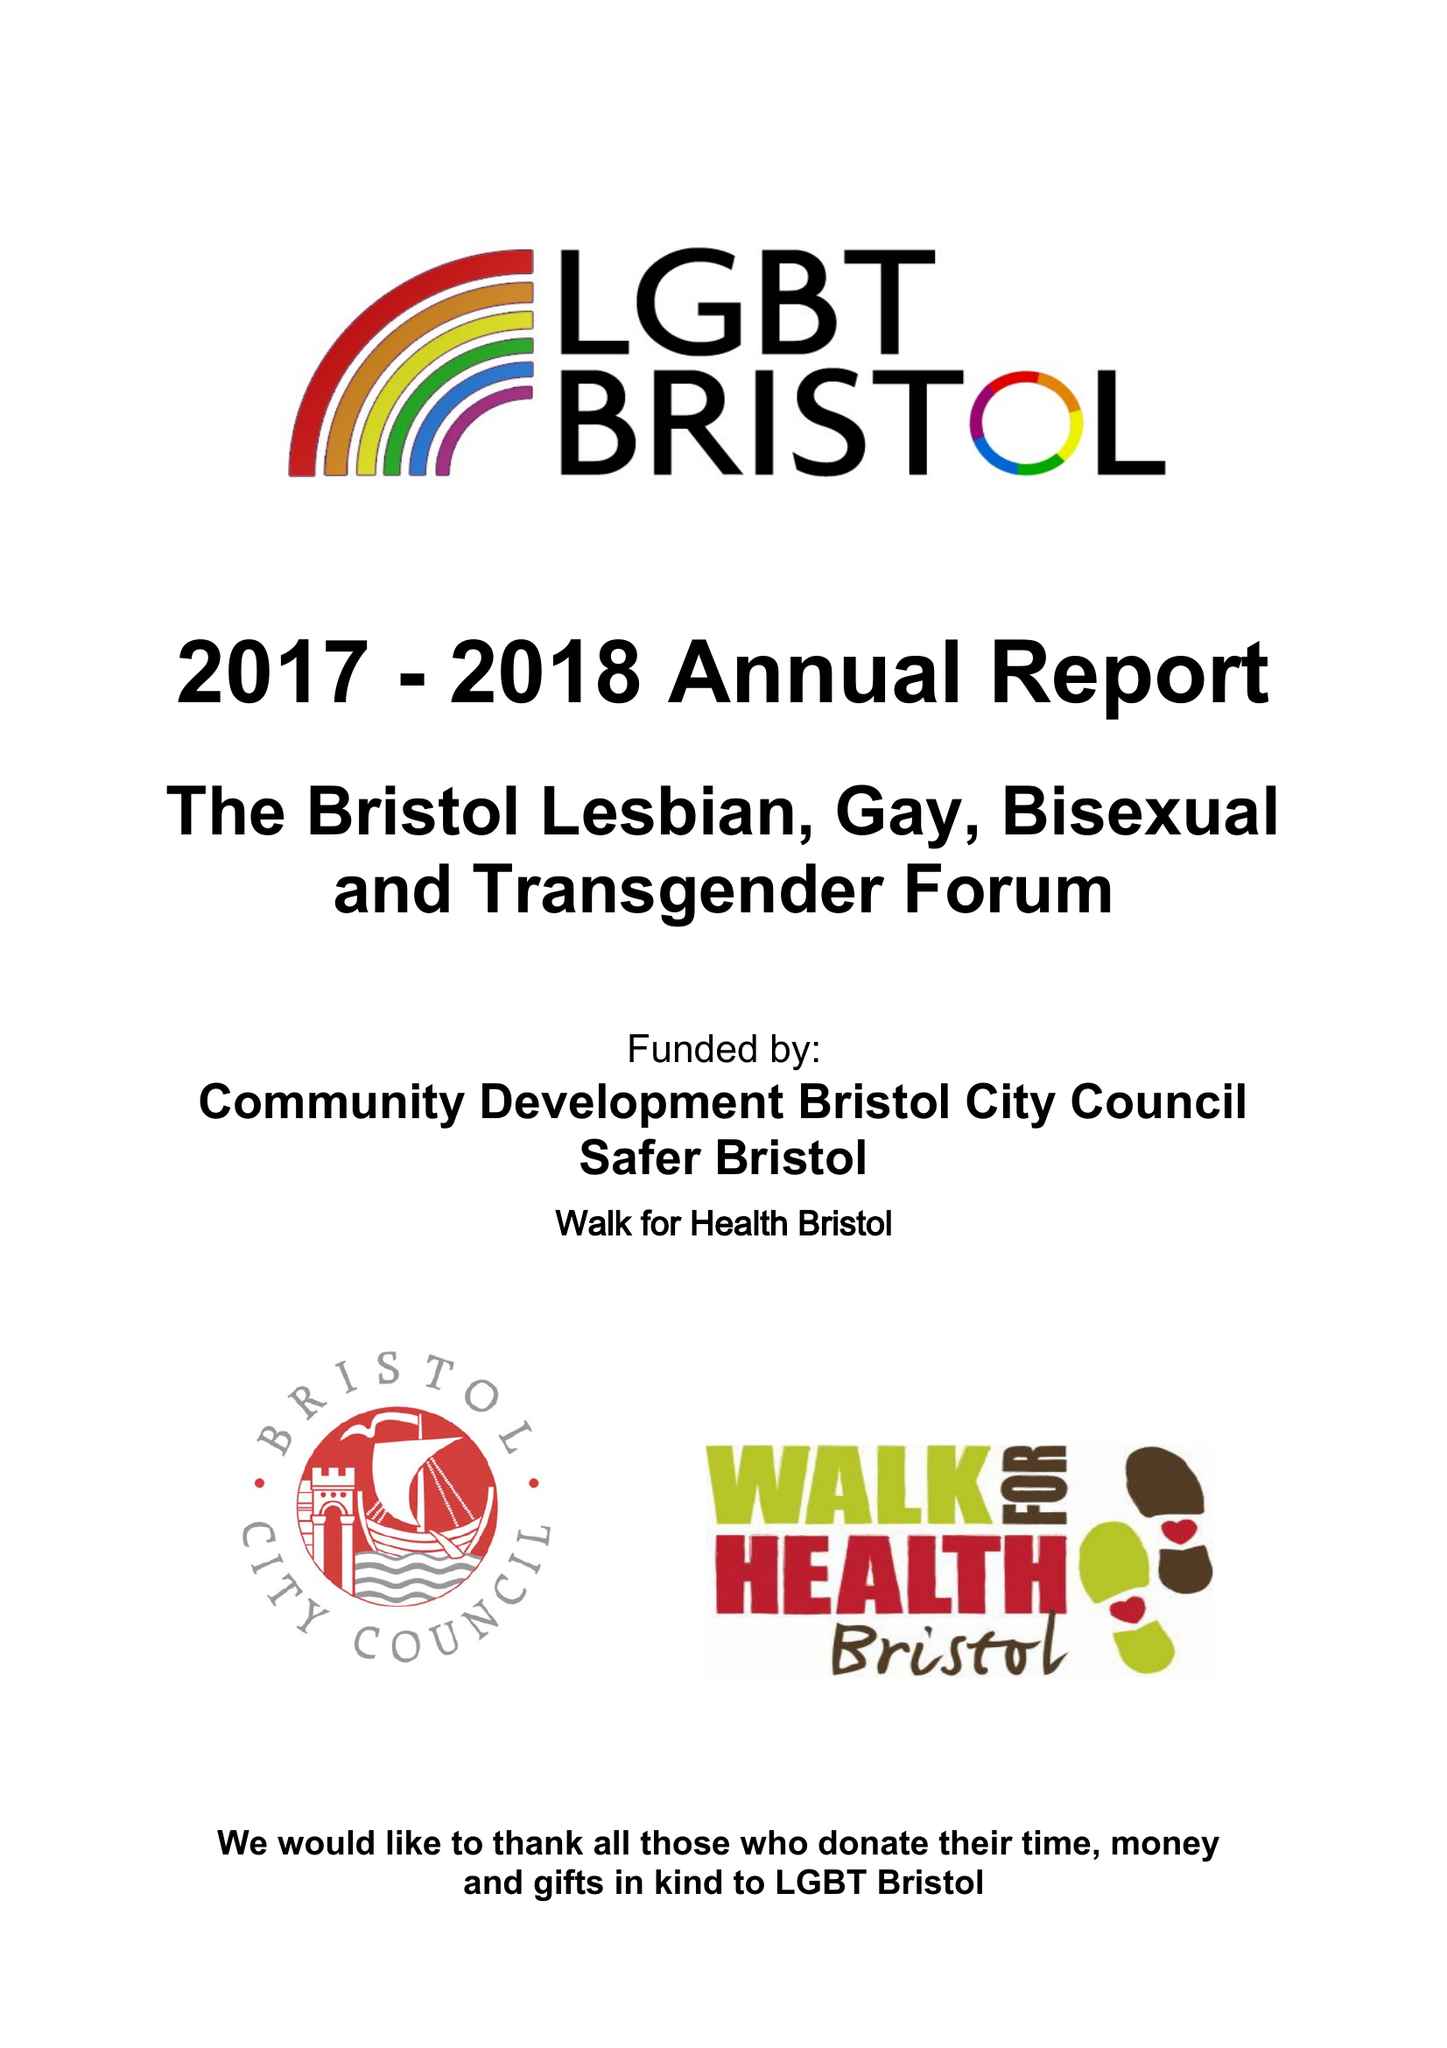What is the value for the spending_annually_in_british_pounds?
Answer the question using a single word or phrase. 50176.00 